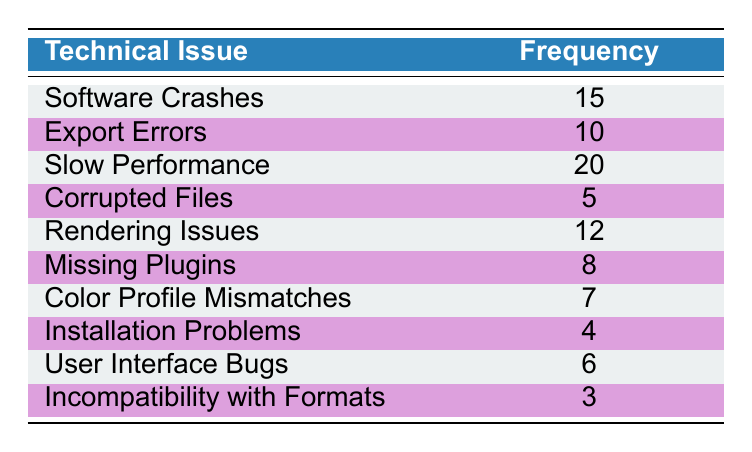What is the most frequently encountered technical issue? The table shows that "Slow Performance" has the highest frequency count of 20 compared to other issues.
Answer: Slow Performance How many technical issues are listed in the table? The table lists a total of 10 unique technical issues under the "Technical Issue" column.
Answer: 10 What is the frequency of "Missing Plugins"? Referring to the table, "Missing Plugins" has a frequency of 8.
Answer: 8 What is the total frequency of issues related to crashes and errors (Software Crashes, Export Errors, and Corrupted Files)? The frequencies for these issues are: Software Crashes = 15, Export Errors = 10, Corrupted Files = 5. Adding these gives: 15 + 10 + 5 = 30.
Answer: 30 Is "Incompatibility with Formats" one of the top three most frequent issues? "Incompatibility with Formats" has a frequency of 3, which is less than the frequencies of the top three issues (Slow Performance, Software Crashes, Export Errors). Thus, it is not among the top three.
Answer: No What is the difference in frequency between the most and least reported issues? The most reported issue is "Slow Performance" at 20, and the least reported is "Incompatibility with Formats" at 3. The difference can be calculated as: 20 - 3 = 17.
Answer: 17 What percentage of the total reported issues does "Rendering Issues" represent? First, we add up the frequencies: 15 + 10 + 20 + 5 + 12 + 8 + 7 + 4 + 6 + 3 = 90. Then, Rendering Issues has a frequency of 12. The percentage is calculated by (12/90) × 100 = 13.33%.
Answer: 13.33% Which issue appears to have a median frequency based on the sorted frequencies? Sorting frequencies in ascending order gives the following sequence: 3, 4, 5, 6, 7, 8, 10, 12, 15, 20. The median will be the average of the 5th and 6th values, which are 7 and 8: (7 + 8) / 2 = 7.5.
Answer: 7.5 What are the two most common issues combined in frequency? The two most common issues are "Slow Performance" (20) and "Software Crashes" (15). The combined frequency is: 20 + 15 = 35.
Answer: 35 